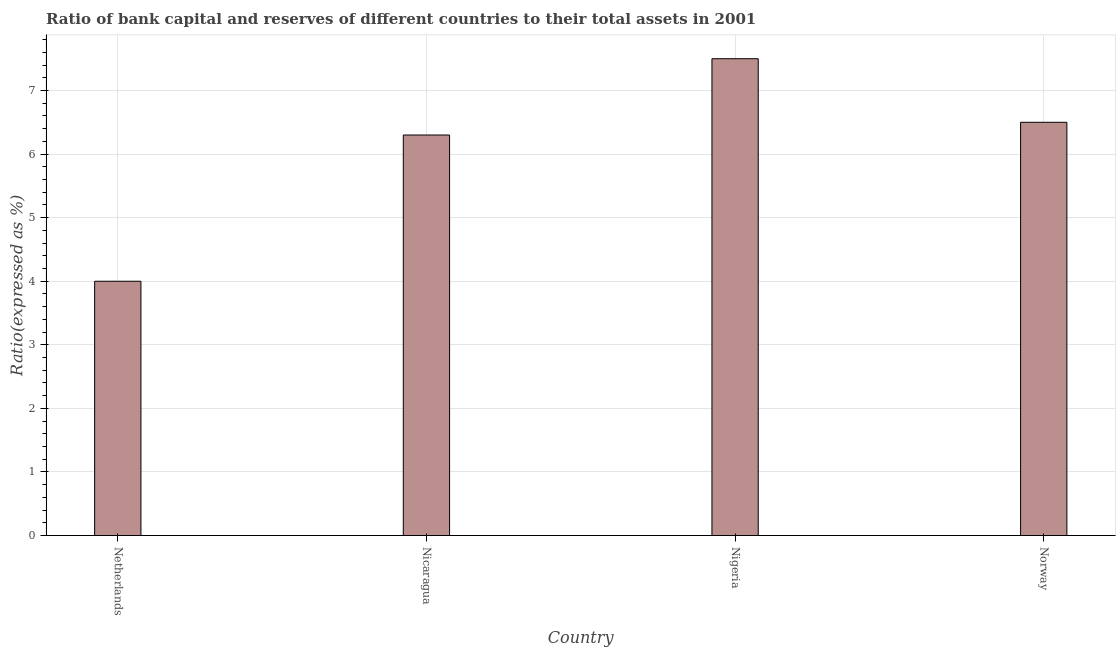Does the graph contain grids?
Give a very brief answer. Yes. What is the title of the graph?
Provide a short and direct response. Ratio of bank capital and reserves of different countries to their total assets in 2001. What is the label or title of the X-axis?
Offer a very short reply. Country. What is the label or title of the Y-axis?
Offer a very short reply. Ratio(expressed as %). Across all countries, what is the maximum bank capital to assets ratio?
Provide a short and direct response. 7.5. Across all countries, what is the minimum bank capital to assets ratio?
Provide a succinct answer. 4. In which country was the bank capital to assets ratio maximum?
Your response must be concise. Nigeria. In which country was the bank capital to assets ratio minimum?
Offer a very short reply. Netherlands. What is the sum of the bank capital to assets ratio?
Offer a terse response. 24.3. What is the difference between the bank capital to assets ratio in Netherlands and Nigeria?
Ensure brevity in your answer.  -3.5. What is the average bank capital to assets ratio per country?
Offer a terse response. 6.08. In how many countries, is the bank capital to assets ratio greater than 5.4 %?
Offer a terse response. 3. What is the ratio of the bank capital to assets ratio in Nicaragua to that in Norway?
Give a very brief answer. 0.97. Is the difference between the bank capital to assets ratio in Netherlands and Nigeria greater than the difference between any two countries?
Your response must be concise. Yes. Is the sum of the bank capital to assets ratio in Netherlands and Nigeria greater than the maximum bank capital to assets ratio across all countries?
Your response must be concise. Yes. What is the difference between the highest and the lowest bank capital to assets ratio?
Provide a succinct answer. 3.5. In how many countries, is the bank capital to assets ratio greater than the average bank capital to assets ratio taken over all countries?
Your response must be concise. 3. Are all the bars in the graph horizontal?
Your response must be concise. No. Are the values on the major ticks of Y-axis written in scientific E-notation?
Give a very brief answer. No. What is the Ratio(expressed as %) in Norway?
Your answer should be very brief. 6.5. What is the difference between the Ratio(expressed as %) in Netherlands and Norway?
Provide a succinct answer. -2.5. What is the ratio of the Ratio(expressed as %) in Netherlands to that in Nicaragua?
Your response must be concise. 0.64. What is the ratio of the Ratio(expressed as %) in Netherlands to that in Nigeria?
Provide a short and direct response. 0.53. What is the ratio of the Ratio(expressed as %) in Netherlands to that in Norway?
Offer a terse response. 0.61. What is the ratio of the Ratio(expressed as %) in Nicaragua to that in Nigeria?
Give a very brief answer. 0.84. What is the ratio of the Ratio(expressed as %) in Nicaragua to that in Norway?
Your response must be concise. 0.97. What is the ratio of the Ratio(expressed as %) in Nigeria to that in Norway?
Give a very brief answer. 1.15. 